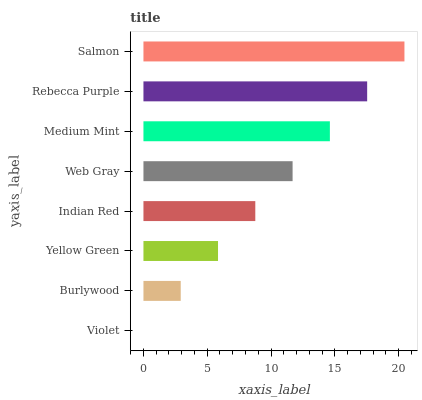Is Violet the minimum?
Answer yes or no. Yes. Is Salmon the maximum?
Answer yes or no. Yes. Is Burlywood the minimum?
Answer yes or no. No. Is Burlywood the maximum?
Answer yes or no. No. Is Burlywood greater than Violet?
Answer yes or no. Yes. Is Violet less than Burlywood?
Answer yes or no. Yes. Is Violet greater than Burlywood?
Answer yes or no. No. Is Burlywood less than Violet?
Answer yes or no. No. Is Web Gray the high median?
Answer yes or no. Yes. Is Indian Red the low median?
Answer yes or no. Yes. Is Yellow Green the high median?
Answer yes or no. No. Is Yellow Green the low median?
Answer yes or no. No. 